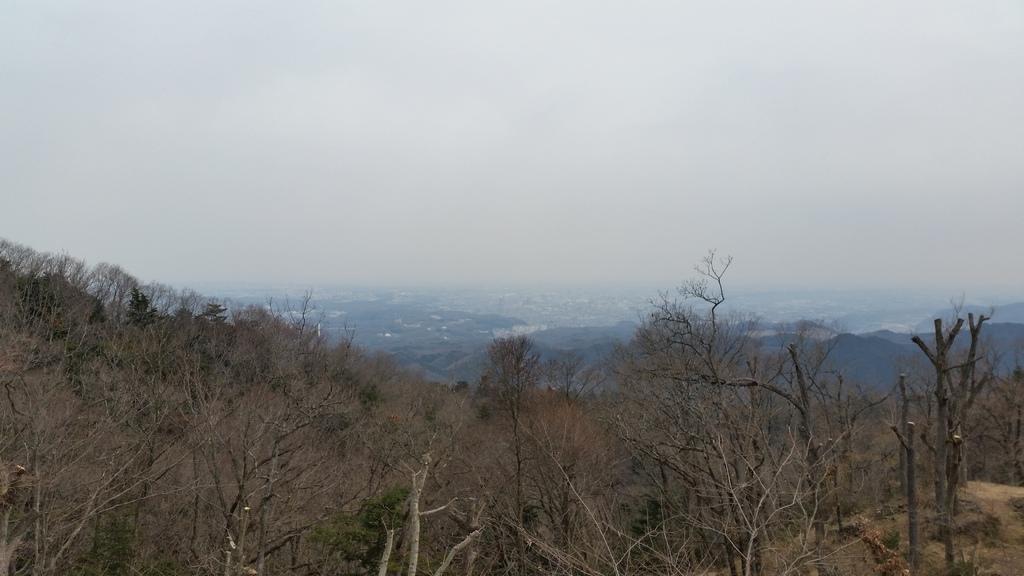Can you describe this image briefly? In this picture we can see some dry trees in the front bottom side. Behind there are some mountains. 